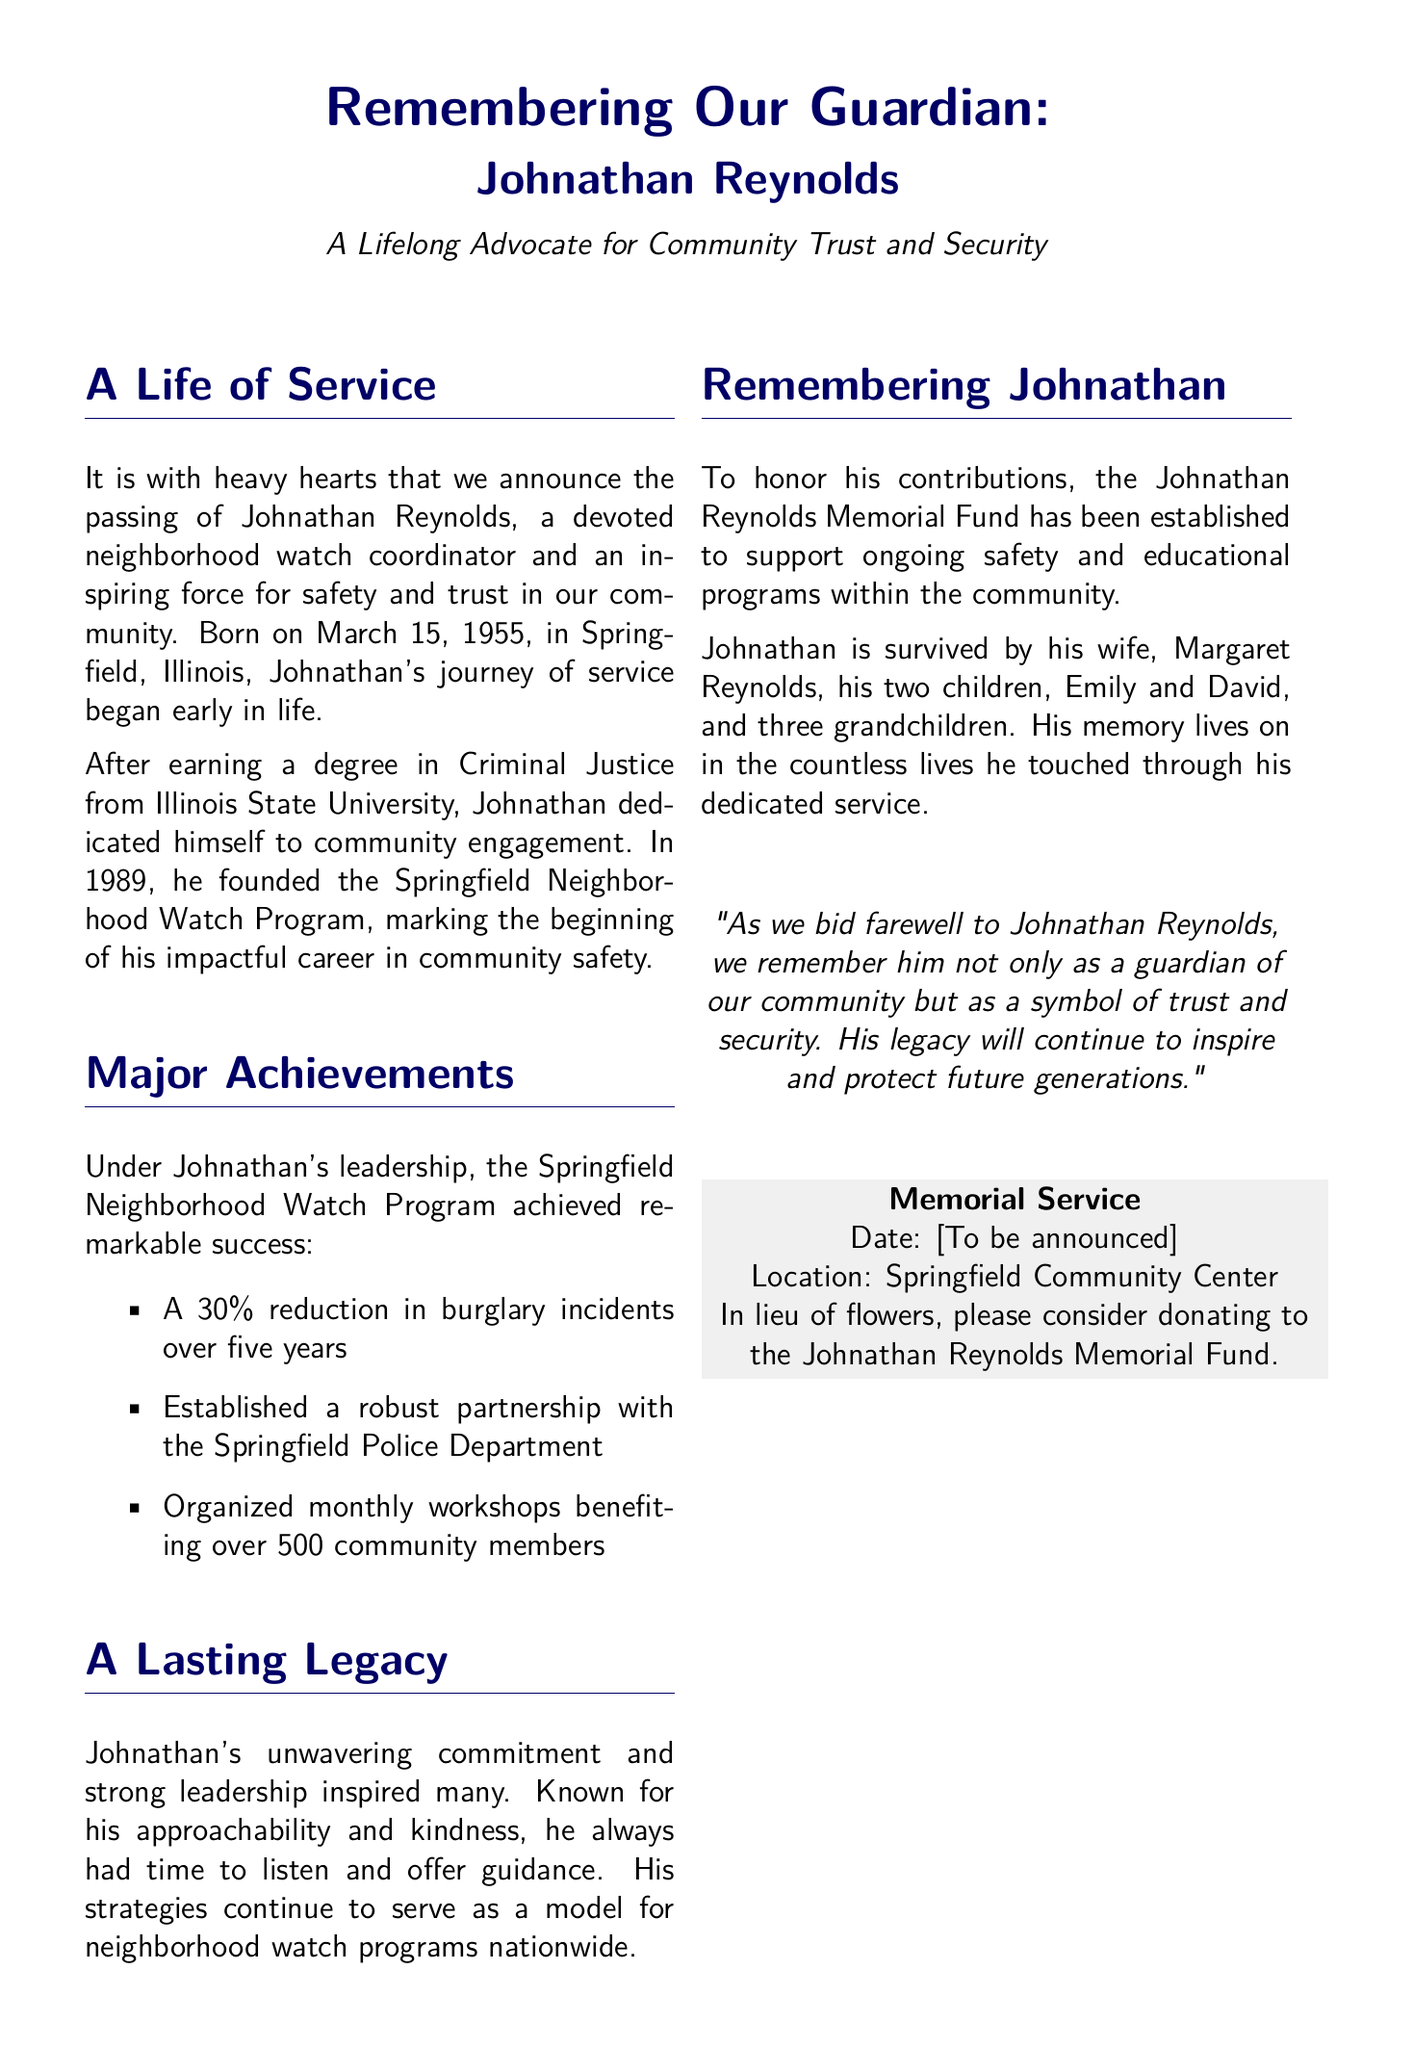What is Johnathan Reynolds' birth date? The document states that Johnathan Reynolds was born on March 15, 1955.
Answer: March 15, 1955 What program did Johnathan found in 1989? It mentions that Johnathan founded the Springfield Neighborhood Watch Program in 1989.
Answer: Springfield Neighborhood Watch Program How much did burglary incidents reduce over five years? The document indicates a 30% reduction in burglary incidents.
Answer: 30% Who is listed as Johnathan's wife? The obituary mentions that Johnathan is survived by his wife, Margaret Reynolds.
Answer: Margaret Reynolds What is the purpose of the Johnathan Reynolds Memorial Fund? The fund supports ongoing safety and educational programs within the community.
Answer: Ongoing safety and educational programs What type of degree did Johnathan earn? The obituary states that Johnathan earned a degree in Criminal Justice.
Answer: Criminal Justice Why is Johnathan Reynolds described as a symbol of trust and security? The statement reflects his impact and contributions to community safety and engagement throughout his life.
Answer: Impact and contributions to community safety When is the memorial service location? The document mentions the memorial service will take place at Springfield Community Center, with the date to be announced.
Answer: Springfield Community Center 